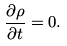Convert formula to latex. <formula><loc_0><loc_0><loc_500><loc_500>\frac { \partial \rho } { \partial t } = 0 .</formula> 